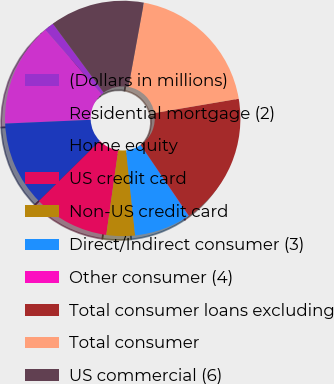<chart> <loc_0><loc_0><loc_500><loc_500><pie_chart><fcel>(Dollars in millions)<fcel>Residential mortgage (2)<fcel>Home equity<fcel>US credit card<fcel>Non-US credit card<fcel>Direct/Indirect consumer (3)<fcel>Other consumer (4)<fcel>Total consumer loans excluding<fcel>Total consumer<fcel>US commercial (6)<nl><fcel>1.32%<fcel>14.27%<fcel>11.68%<fcel>10.39%<fcel>3.91%<fcel>7.8%<fcel>0.03%<fcel>18.16%<fcel>19.45%<fcel>12.98%<nl></chart> 